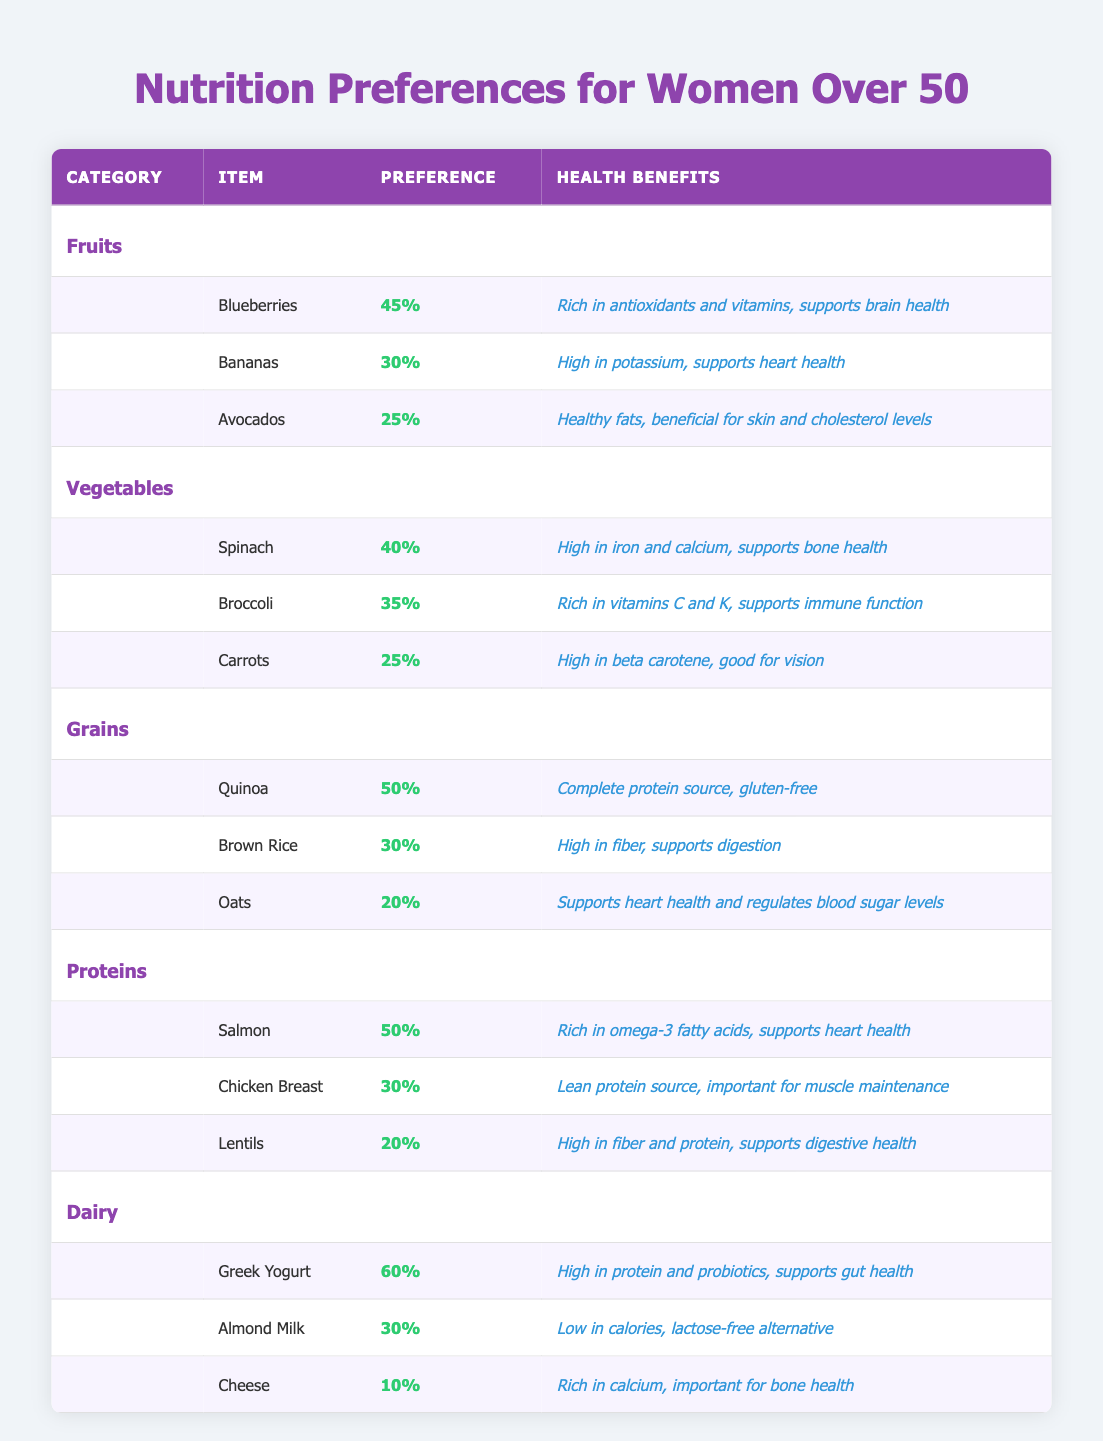What is the most preferred fruit among women over 50 years old? The table lists the fruit preferences with their percentage values. Blueberries have the highest percentage at 45%, making them the most preferred fruit.
Answer: Blueberries Which vegetable has the lowest preference percentage? Looking at the vegetable category, Carrots have the lowest preference percentage at 25%.
Answer: Carrots What is the average preference percentage for grains? The grain preferences are Quinoa (50%), Brown Rice (30%), and Oats (20%). To find the average, we sum the percentages (50 + 30 + 20 = 100) and then divide by the number of items (100 / 3), which equals approximately 33.33%.
Answer: 33.33% True or False: Avocados have a preference percentage greater than 25%. In the table, Avocados have a preference of 25%. The statement requires them to be greater, which is not true as 25 is not greater than 25.
Answer: False Which category contains the highest percentage item, and what is that item? The Dairy category shows Greek Yogurt with the highest percentage at 60%. This is higher than any other item across all categories.
Answer: Dairy; Greek Yogurt What is the total preference percentage for all protein sources listed in the table? The protein sources listed are Salmon (50%), Chicken Breast (30%), and Lentils (20%). Adding these gives (50 + 30 + 20 = 100), so the total preference percentage for proteins is 100%.
Answer: 100% Which dairy option has the least preference among women over 50 years old? The dairy options are Greek Yogurt (60%), Almond Milk (30%), and Cheese (10%). Cheese has the lowest preference percentage at 10%.
Answer: Cheese How do the preference percentages for fruits compare to those for vegetables? For fruits, the preferences are Blueberries (45%), Bananas (30%), and Avocados (25%). The vegetable preferences are Spinach (40%), Broccoli (35%), and Carrots (25%). The total for fruits is (45 + 30 + 25 = 100) and for vegetables is (40 + 35 + 25 = 100). In terms of preferences, they are equal in total percentages, but individual preferences vary.
Answer: They are equal What is the health benefit of the most preferred dairy product? The most preferred dairy product is Greek Yogurt with a preference of 60%. Its health benefit is that it is high in protein and probiotics, which supports gut health.
Answer: High in protein and probiotics 